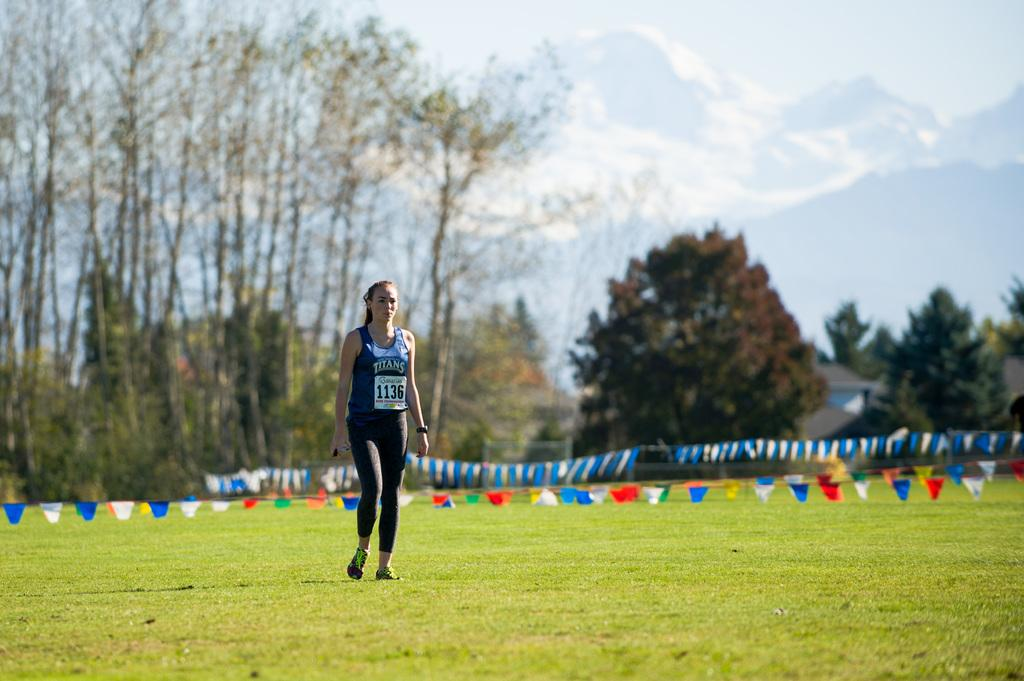<image>
Describe the image concisely. A runner wearing 1136 is standing in a field 